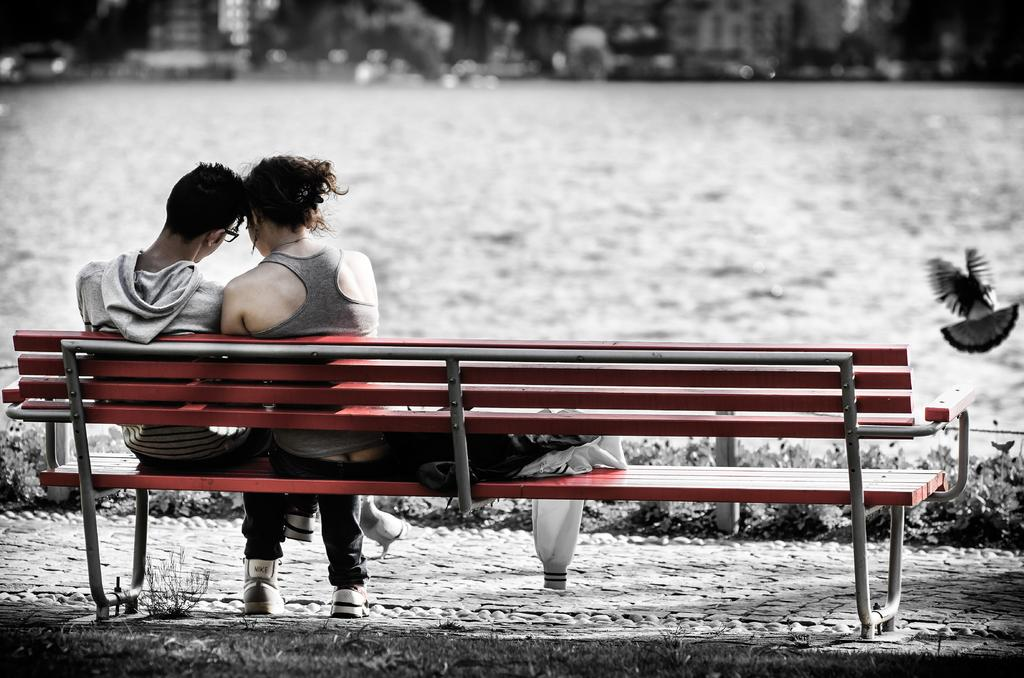What are the two people in the image doing? There is a couple sitting on a bench in the image. What else can be seen near the couple? There are clothes beside the couple. What type of footwear are the man and woman wearing? Both the man and woman are wearing shoes. What can be seen in the background of the image? There is a body of water and a bird visible in the background. What type of comb is the bird using to groom itself in the image? There is no comb present in the image, and the bird is not grooming itself. 